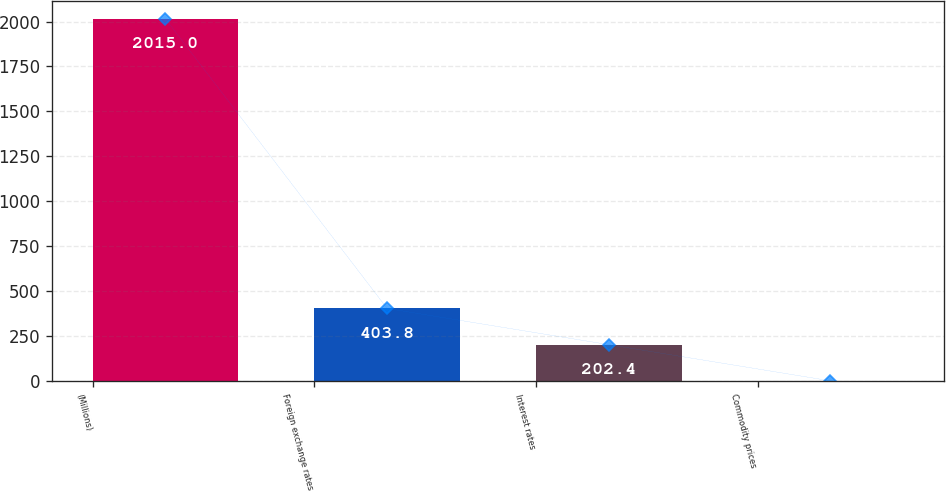Convert chart to OTSL. <chart><loc_0><loc_0><loc_500><loc_500><bar_chart><fcel>(Millions)<fcel>Foreign exchange rates<fcel>Interest rates<fcel>Commodity prices<nl><fcel>2015<fcel>403.8<fcel>202.4<fcel>1<nl></chart> 